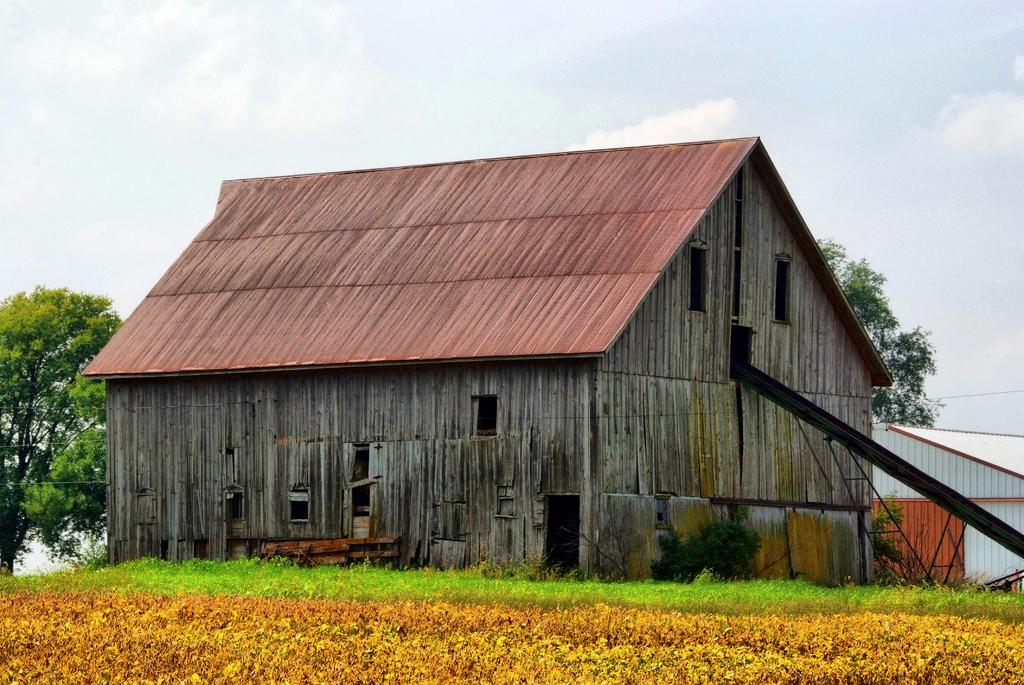What type of structure is present in the image? There is a building in the image. What is located near the building? There is grass and plants near the building. What can be seen in the background of the image? There are trees and the sky visible in the background of the image. Can you describe the objects on the right side of the image? There are rods on the right side of the image. What type of root can be seen growing near the building in the image? There is no root visible in the image; it only shows a building, grass, plants, trees, sky, and rods. What territory does the building in the image belong to? The image does not provide information about the territory or ownership of the building. 